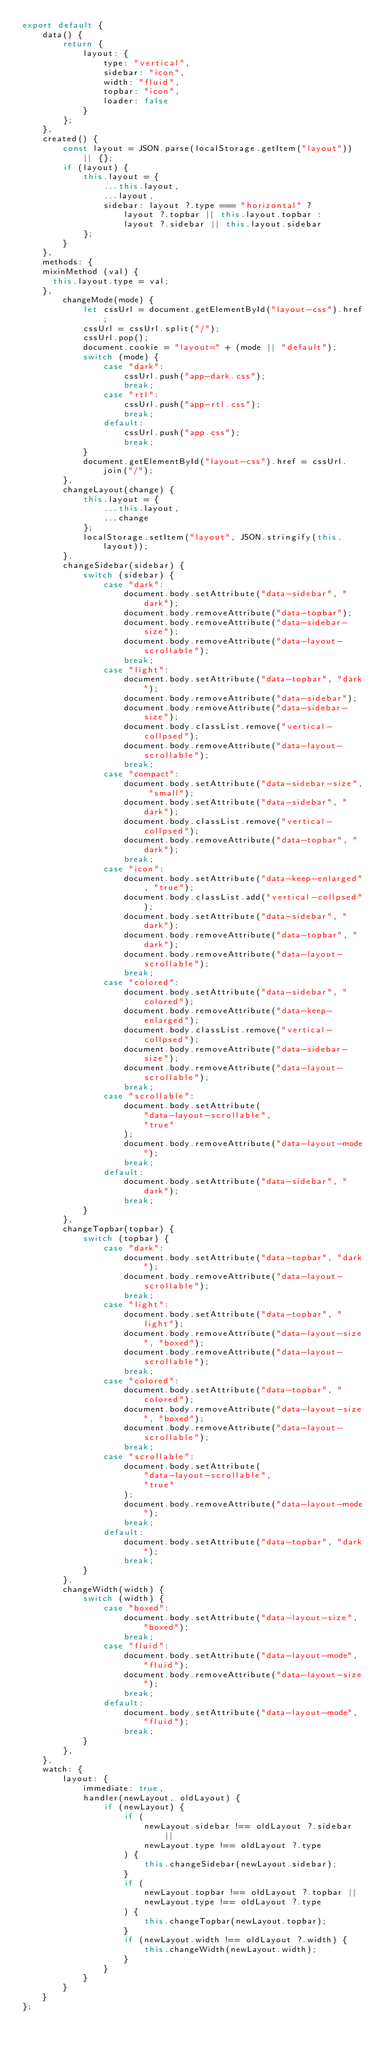<code> <loc_0><loc_0><loc_500><loc_500><_JavaScript_>export default {
    data() {
        return {
            layout: {
                type: "vertical",
                sidebar: "icon",
                width: "fluid",
                topbar: "icon",
                loader: false
            }
        };
    },
    created() {
        const layout = JSON.parse(localStorage.getItem("layout")) || {};
        if (layout) {
            this.layout = {
                ...this.layout,
                ...layout,
                sidebar: layout ?.type === "horizontal" ?
                    layout ?.topbar || this.layout.topbar :
                    layout ?.sidebar || this.layout.sidebar
            };
        }
    },
    methods: {
		mixinMethod (val) {
			this.layout.type = val;
		},
        changeMode(mode) {
            let cssUrl = document.getElementById("layout-css").href;
            cssUrl = cssUrl.split("/");
            cssUrl.pop();
            document.cookie = "layout=" + (mode || "default");
            switch (mode) {
                case "dark":
                    cssUrl.push("app-dark.css");
                    break;
                case "rtl":
                    cssUrl.push("app-rtl.css");
                    break;
                default:
                    cssUrl.push("app.css");
                    break;
            }
            document.getElementById("layout-css").href = cssUrl.join("/");
        },
        changeLayout(change) {
            this.layout = {
                ...this.layout,
                ...change
            };
            localStorage.setItem("layout", JSON.stringify(this.layout));
        },
        changeSidebar(sidebar) {
            switch (sidebar) {
                case "dark":
                    document.body.setAttribute("data-sidebar", "dark");
                    document.body.removeAttribute("data-topbar");
                    document.body.removeAttribute("data-sidebar-size");
                    document.body.removeAttribute("data-layout-scrollable");
                    break;
                case "light":
                    document.body.setAttribute("data-topbar", "dark");
                    document.body.removeAttribute("data-sidebar");
                    document.body.removeAttribute("data-sidebar-size");
                    document.body.classList.remove("vertical-collpsed");
                    document.body.removeAttribute("data-layout-scrollable");
                    break;
                case "compact":
                    document.body.setAttribute("data-sidebar-size", "small");
                    document.body.setAttribute("data-sidebar", "dark");
                    document.body.classList.remove("vertical-collpsed");
                    document.body.removeAttribute("data-topbar", "dark");
                    break;
                case "icon":
                    document.body.setAttribute("data-keep-enlarged", "true");
                    document.body.classList.add("vertical-collpsed");
                    document.body.setAttribute("data-sidebar", "dark");
                    document.body.removeAttribute("data-topbar", "dark");
                    document.body.removeAttribute("data-layout-scrollable");
                    break;
                case "colored":
                    document.body.setAttribute("data-sidebar", "colored");
                    document.body.removeAttribute("data-keep-enlarged");
                    document.body.classList.remove("vertical-collpsed");
                    document.body.removeAttribute("data-sidebar-size");
                    document.body.removeAttribute("data-layout-scrollable");
                    break;
                case "scrollable":
                    document.body.setAttribute(
                        "data-layout-scrollable",
                        "true"
                    );
                    document.body.removeAttribute("data-layout-mode");
                    break;
                default:
                    document.body.setAttribute("data-sidebar", "dark");
                    break;
            }
        },
        changeTopbar(topbar) {
            switch (topbar) {
                case "dark":
                    document.body.setAttribute("data-topbar", "dark");
                    document.body.removeAttribute("data-layout-scrollable");
                    break;
                case "light":
                    document.body.setAttribute("data-topbar", "light");
                    document.body.removeAttribute("data-layout-size", "boxed");
                    document.body.removeAttribute("data-layout-scrollable");
                    break;
                case "colored":
                    document.body.setAttribute("data-topbar", "colored");
                    document.body.removeAttribute("data-layout-size", "boxed");
                    document.body.removeAttribute("data-layout-scrollable");
                    break;
                case "scrollable":
                    document.body.setAttribute(
                        "data-layout-scrollable",
                        "true"
                    );
                    document.body.removeAttribute("data-layout-mode");
                    break;
                default:
                    document.body.setAttribute("data-topbar", "dark");
                    break;
            }
        },
        changeWidth(width) {
            switch (width) {
                case "boxed":
                    document.body.setAttribute("data-layout-size", "boxed");
                    break;
                case "fluid":
                    document.body.setAttribute("data-layout-mode", "fluid");
                    document.body.removeAttribute("data-layout-size");
                    break;
                default:
                    document.body.setAttribute("data-layout-mode", "fluid");
                    break;
            }
        },
    },
    watch: {
        layout: {
            immediate: true,
            handler(newLayout, oldLayout) {
                if (newLayout) {
                    if (
                        newLayout.sidebar !== oldLayout ?.sidebar ||
                        newLayout.type !== oldLayout ?.type
                    ) {
                        this.changeSidebar(newLayout.sidebar);
                    }
                    if (
                        newLayout.topbar !== oldLayout ?.topbar ||
                        newLayout.type !== oldLayout ?.type
                    ) {
                        this.changeTopbar(newLayout.topbar);
                    }
                    if (newLayout.width !== oldLayout ?.width) {
                        this.changeWidth(newLayout.width);
                    }
                }
            }
        }
    }
};</code> 